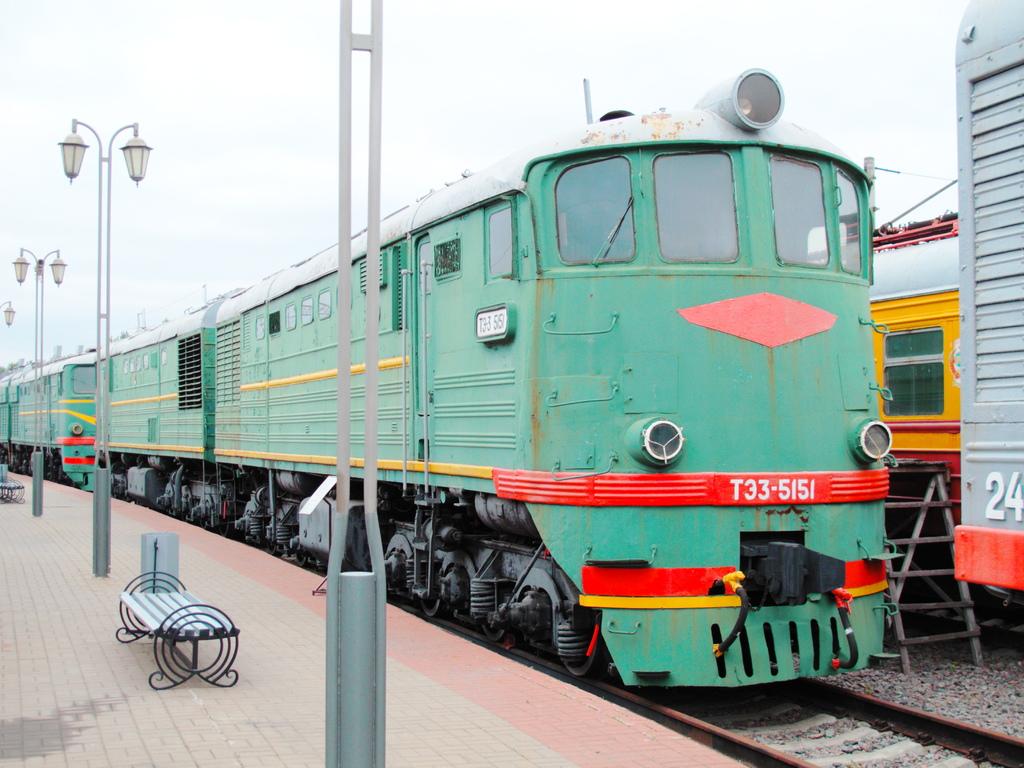What number is the green train?
Offer a very short reply. T33-5151. What is the train number?
Your answer should be very brief. T33-5151. 